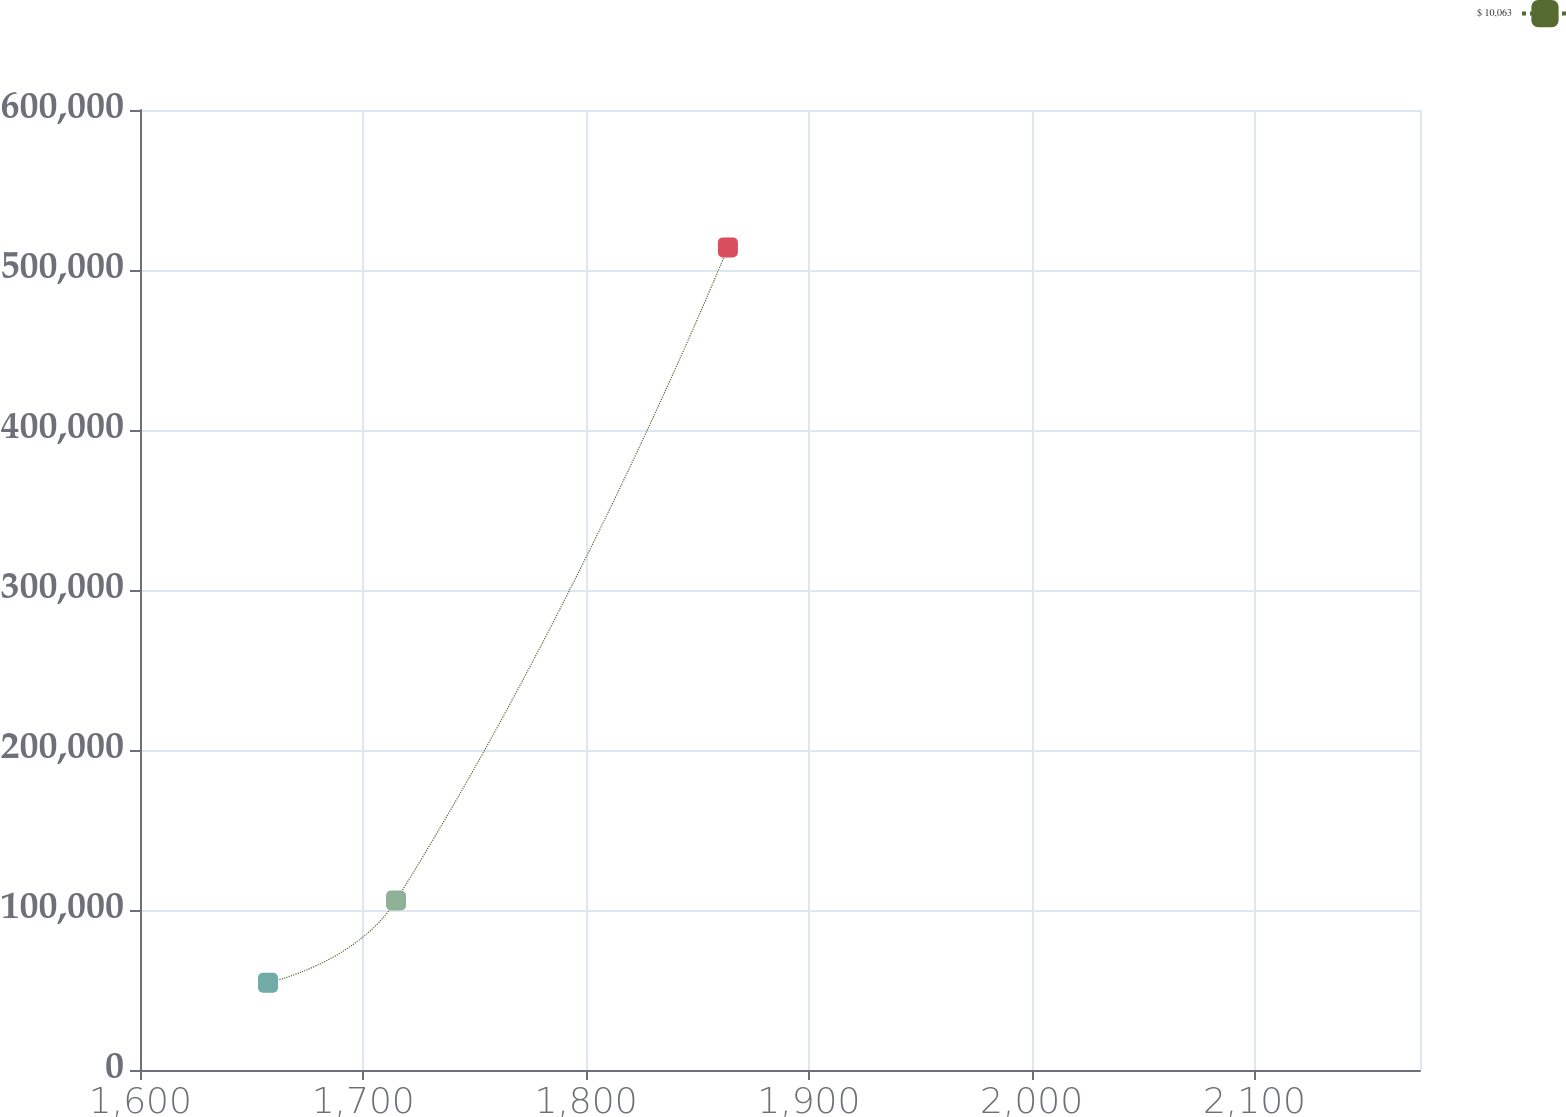Convert chart to OTSL. <chart><loc_0><loc_0><loc_500><loc_500><line_chart><ecel><fcel>$ 10,063<nl><fcel>1657.27<fcel>54583.9<nl><fcel>1714.72<fcel>105983<nl><fcel>1863.68<fcel>514125<nl><fcel>2231.74<fcel>134.46<nl></chart> 